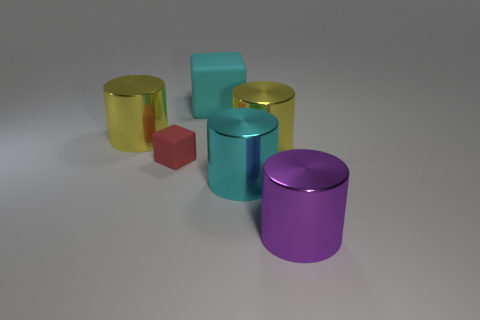Add 2 cyan things. How many objects exist? 8 Subtract all cylinders. How many objects are left? 2 Subtract 1 cyan blocks. How many objects are left? 5 Subtract all large gray rubber spheres. Subtract all large cyan matte things. How many objects are left? 5 Add 3 large yellow metallic things. How many large yellow metallic things are left? 5 Add 4 tiny green matte things. How many tiny green matte things exist? 4 